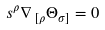Convert formula to latex. <formula><loc_0><loc_0><loc_500><loc_500>s ^ { \rho } \nabla \, _ { [ \rho } \Theta _ { \sigma ] } = 0</formula> 